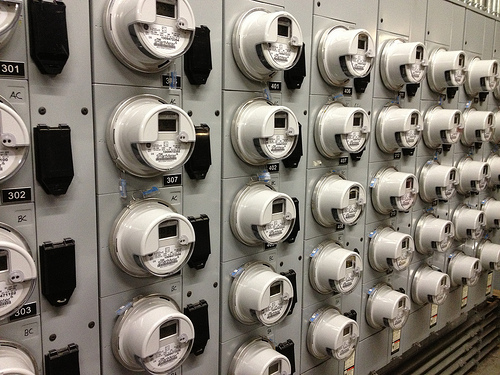<image>
Is there a meter in front of the plug? No. The meter is not in front of the plug. The spatial positioning shows a different relationship between these objects. 